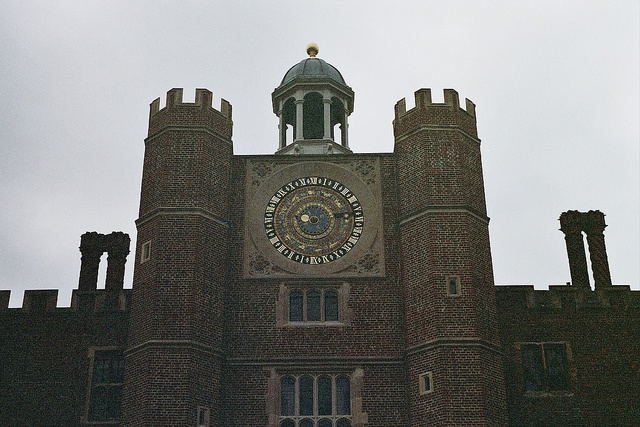Describe the objects in this image and their specific colors. I can see a clock in lightgray, gray, and black tones in this image. 